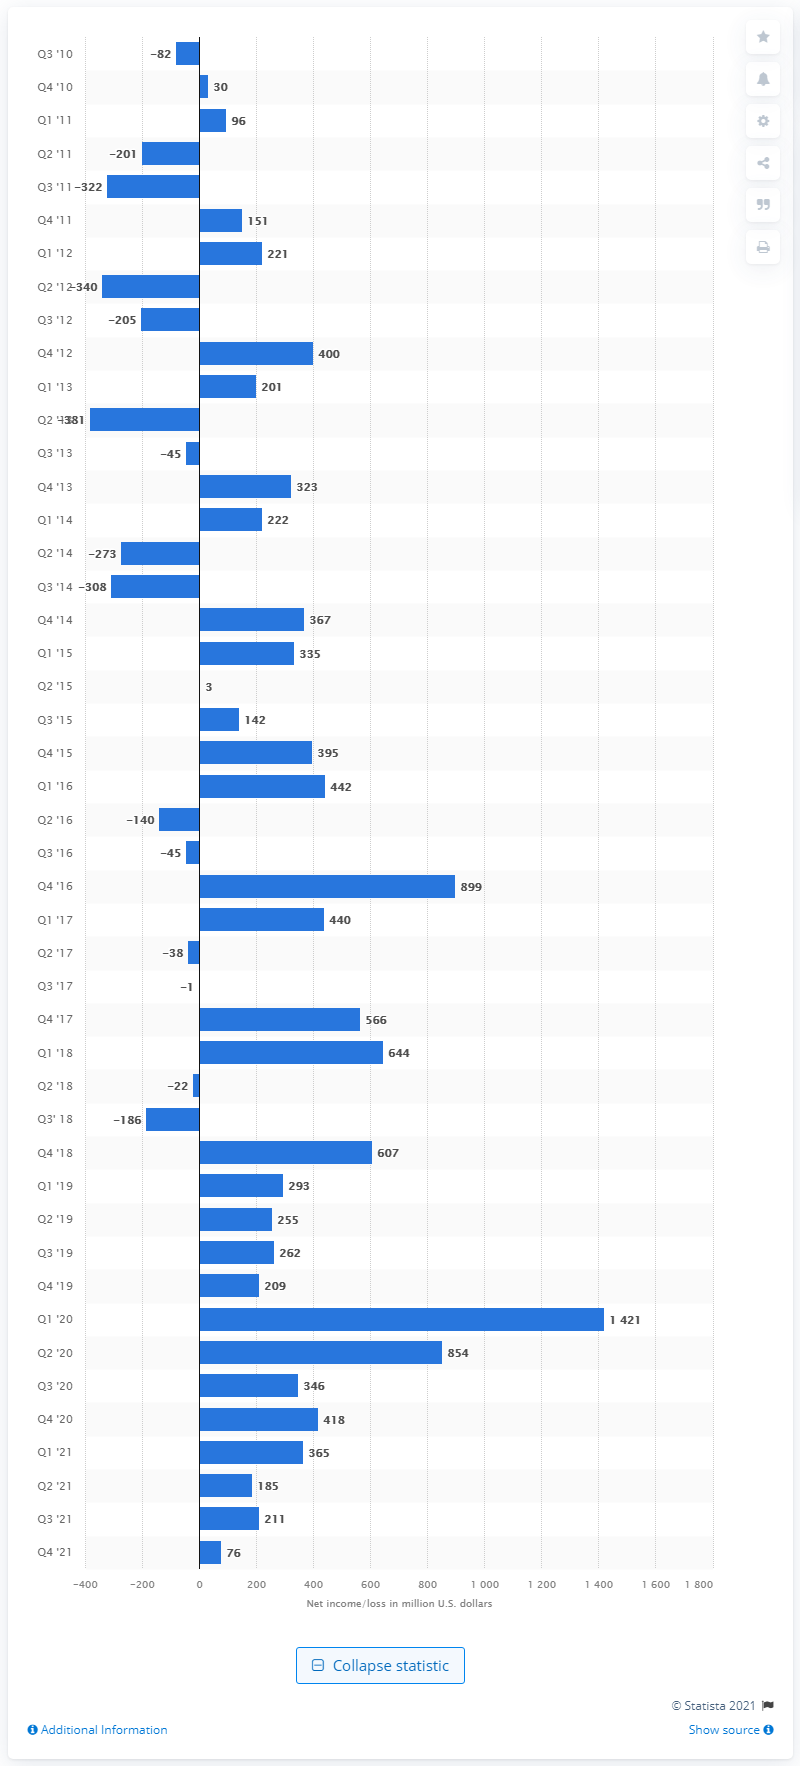List a handful of essential elements in this visual. Electronic Arts' net income in the fourth quarter of 2021 was $76 million. 